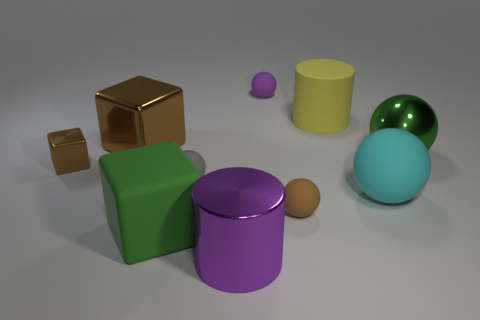Is there a pattern or arrangement to the placement of the objects? The objects seem to be arranged somewhat haphazardly, without a clear pattern. The varying sizes and colors do not follow any apparent order. The arrangement gives a sense of randomness rather than intention, which may suggest a casual or unordered setting. 